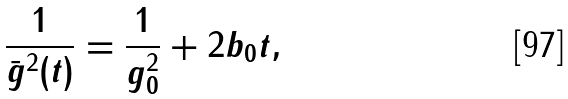<formula> <loc_0><loc_0><loc_500><loc_500>\frac { 1 } { \bar { g } ^ { 2 } ( t ) } = \frac { 1 } { g _ { 0 } ^ { 2 } } + 2 b _ { 0 } t ,</formula> 